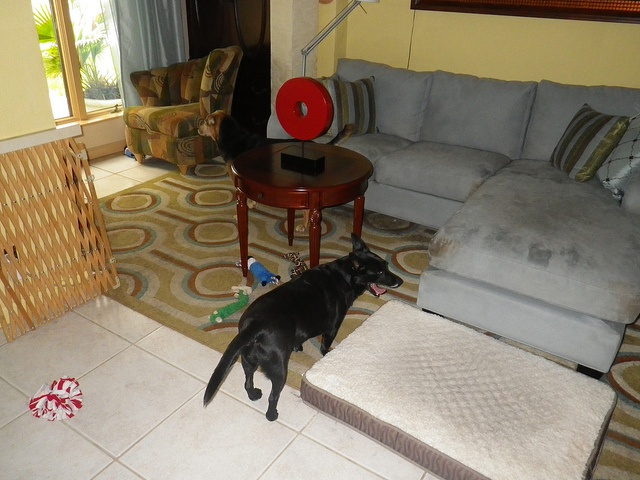Describe the objects in this image and their specific colors. I can see couch in tan, gray, darkgray, black, and maroon tones, dog in tan, black, and gray tones, couch in tan, black, olive, and maroon tones, and chair in tan, black, olive, and maroon tones in this image. 